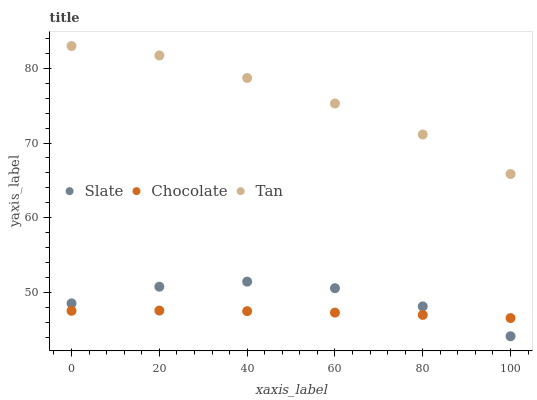Does Chocolate have the minimum area under the curve?
Answer yes or no. Yes. Does Tan have the maximum area under the curve?
Answer yes or no. Yes. Does Tan have the minimum area under the curve?
Answer yes or no. No. Does Chocolate have the maximum area under the curve?
Answer yes or no. No. Is Chocolate the smoothest?
Answer yes or no. Yes. Is Slate the roughest?
Answer yes or no. Yes. Is Tan the smoothest?
Answer yes or no. No. Is Tan the roughest?
Answer yes or no. No. Does Slate have the lowest value?
Answer yes or no. Yes. Does Chocolate have the lowest value?
Answer yes or no. No. Does Tan have the highest value?
Answer yes or no. Yes. Does Chocolate have the highest value?
Answer yes or no. No. Is Chocolate less than Tan?
Answer yes or no. Yes. Is Tan greater than Chocolate?
Answer yes or no. Yes. Does Chocolate intersect Slate?
Answer yes or no. Yes. Is Chocolate less than Slate?
Answer yes or no. No. Is Chocolate greater than Slate?
Answer yes or no. No. Does Chocolate intersect Tan?
Answer yes or no. No. 